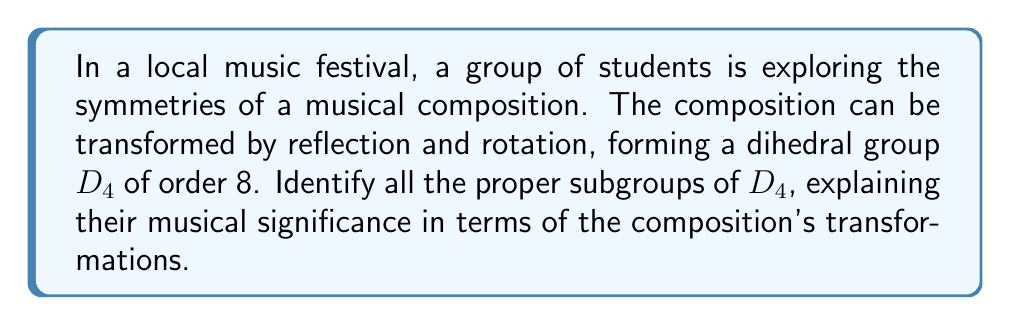What is the answer to this math problem? Let's approach this step-by-step:

1) First, recall that $D_4$ is the symmetry group of a square, with 8 elements:
   - 4 rotations: $e$ (identity), $r$ (90°), $r^2$ (180°), $r^3$ (270°)
   - 4 reflections: $s$ (horizontal), $sr$ (diagonal), $sr^2$ (vertical), $sr^3$ (other diagonal)

2) The proper subgroups of $D_4$ are:

   a) Cyclic subgroup of order 4: $\{e, r, r^2, r^3\}$
      Musically, this represents all rotational symmetries of the composition.

   b) Two cyclic subgroups of order 2: $\{e, r^2\}$ and $\{e, s\}$
      $\{e, r^2\}$ represents a 180° rotation, which could be playing the composition backwards.
      $\{e, s\}$ represents a reflection, which could be inverting all intervals in the composition.

   c) Four more subgroups of order 2: $\{e, sr\}$, $\{e, sr^2\}$, $\{e, sr^3\}$, $\{e, s\}$
      These represent the various reflections of the composition.

   d) Klein four-group: $\{e, r^2, s, sr^2\}$
      This combines 180° rotation and two perpendicular reflections, offering a richer set of transformations.

3) The trivial subgroup $\{e\}$ is also a proper subgroup, representing no change to the composition.

In total, there are 9 proper subgroups of $D_4$.

Musically, these subgroups represent different ways the composition can be symmetrically transformed while maintaining its structural integrity. Rotations could represent playing the piece in different orientations, while reflections could represent inverting melodies or harmonies.
Answer: The dihedral group $D_4$ has 9 proper subgroups:
1 subgroup of order 4: $\{e, r, r^2, r^3\}$
5 subgroups of order 2: $\{e, r^2\}$, $\{e, s\}$, $\{e, sr\}$, $\{e, sr^2\}$, $\{e, sr^3\}$
1 Klein four-group: $\{e, r^2, s, sr^2\}$
1 trivial subgroup: $\{e\}$
Each subgroup represents a specific set of symmetrical transformations applicable to the musical composition. 